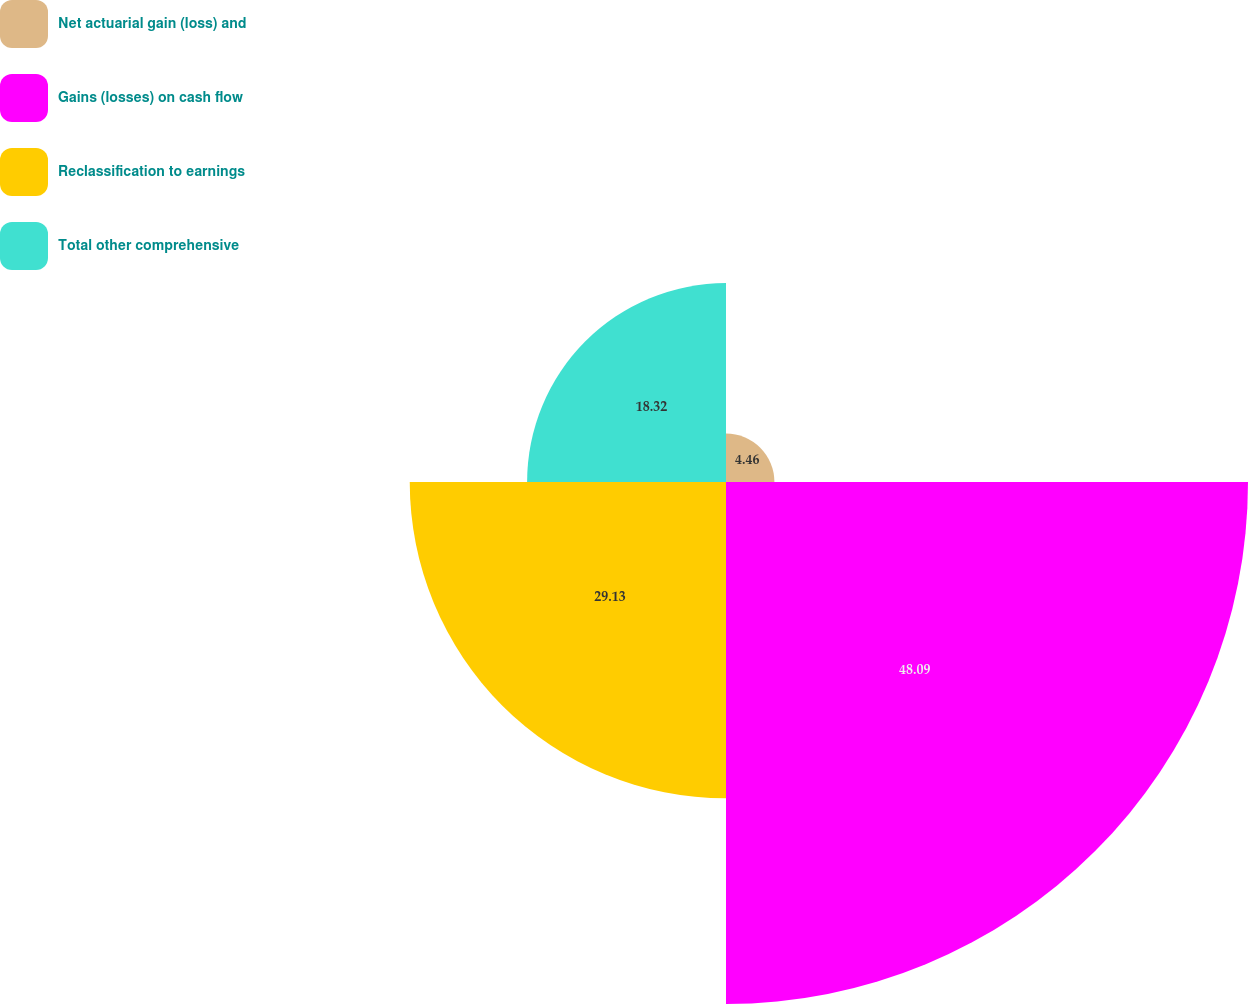Convert chart to OTSL. <chart><loc_0><loc_0><loc_500><loc_500><pie_chart><fcel>Net actuarial gain (loss) and<fcel>Gains (losses) on cash flow<fcel>Reclassification to earnings<fcel>Total other comprehensive<nl><fcel>4.46%<fcel>48.08%<fcel>29.13%<fcel>18.32%<nl></chart> 